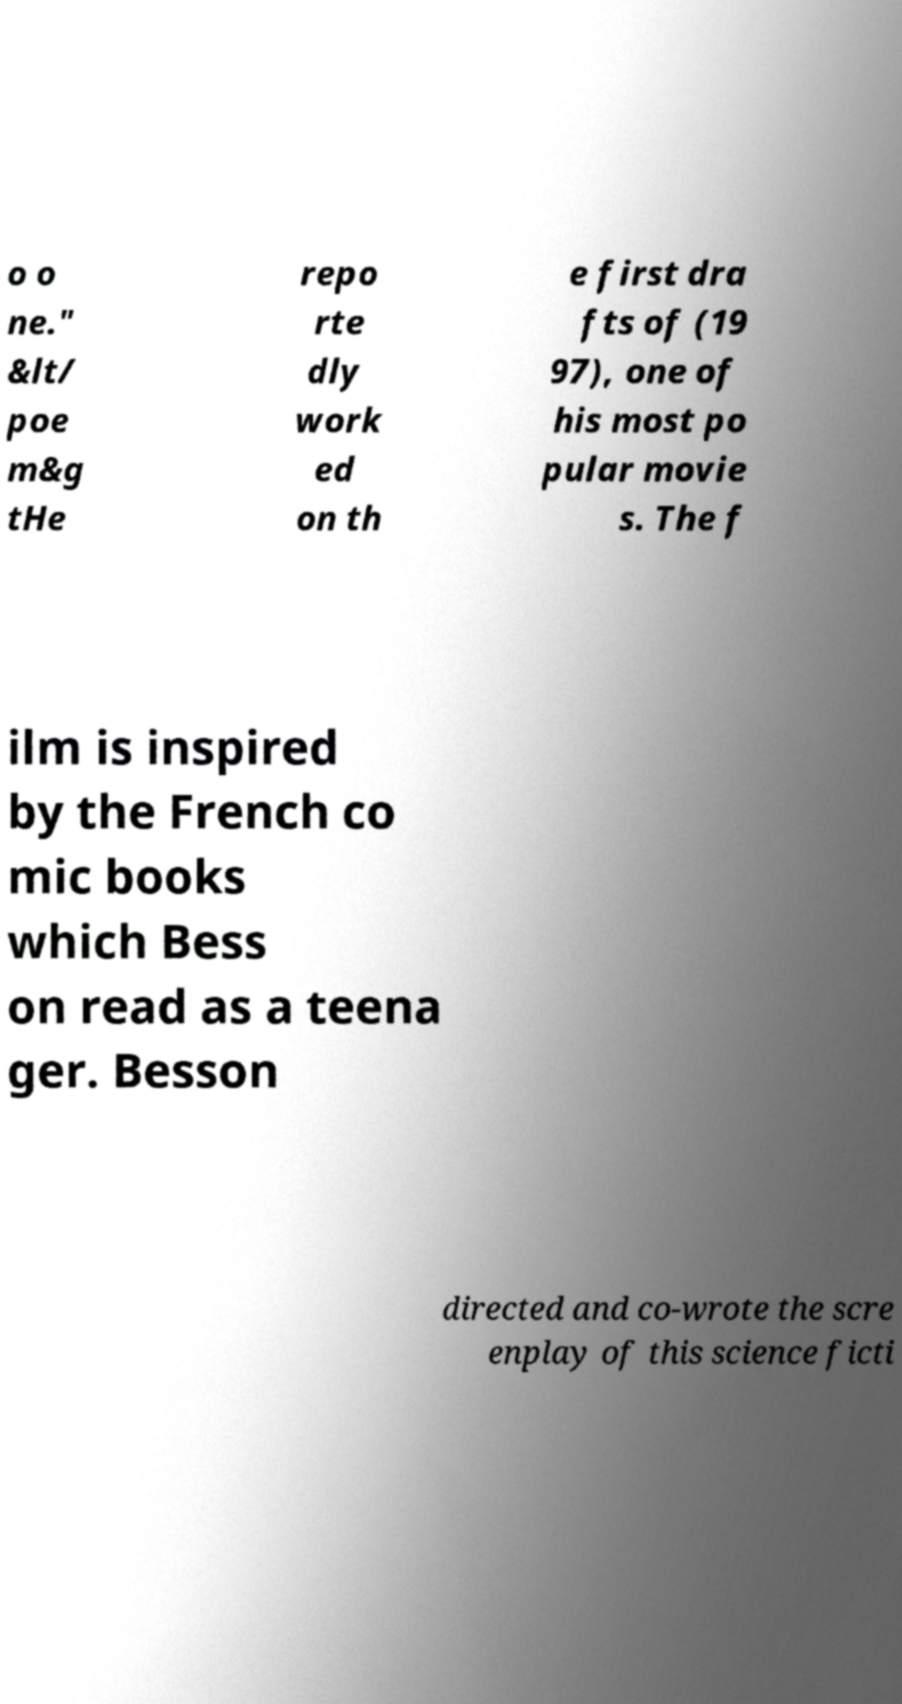For documentation purposes, I need the text within this image transcribed. Could you provide that? o o ne." &lt/ poe m&g tHe repo rte dly work ed on th e first dra fts of (19 97), one of his most po pular movie s. The f ilm is inspired by the French co mic books which Bess on read as a teena ger. Besson directed and co-wrote the scre enplay of this science ficti 